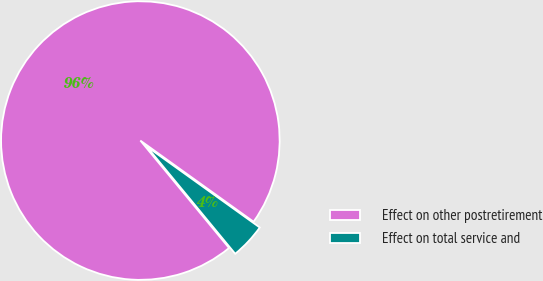Convert chart to OTSL. <chart><loc_0><loc_0><loc_500><loc_500><pie_chart><fcel>Effect on other postretirement<fcel>Effect on total service and<nl><fcel>95.88%<fcel>4.12%<nl></chart> 